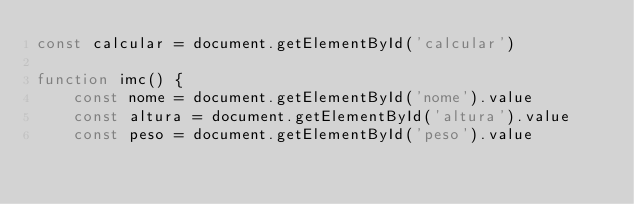<code> <loc_0><loc_0><loc_500><loc_500><_JavaScript_>const calcular = document.getElementById('calcular')

function imc() {
    const nome = document.getElementById('nome').value
    const altura = document.getElementById('altura').value
    const peso = document.getElementById('peso').value</code> 